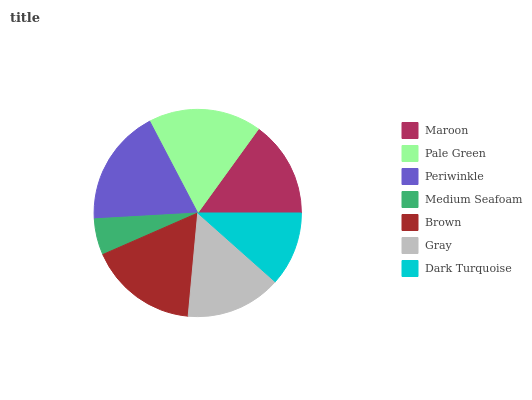Is Medium Seafoam the minimum?
Answer yes or no. Yes. Is Periwinkle the maximum?
Answer yes or no. Yes. Is Pale Green the minimum?
Answer yes or no. No. Is Pale Green the maximum?
Answer yes or no. No. Is Pale Green greater than Maroon?
Answer yes or no. Yes. Is Maroon less than Pale Green?
Answer yes or no. Yes. Is Maroon greater than Pale Green?
Answer yes or no. No. Is Pale Green less than Maroon?
Answer yes or no. No. Is Maroon the high median?
Answer yes or no. Yes. Is Maroon the low median?
Answer yes or no. Yes. Is Medium Seafoam the high median?
Answer yes or no. No. Is Periwinkle the low median?
Answer yes or no. No. 